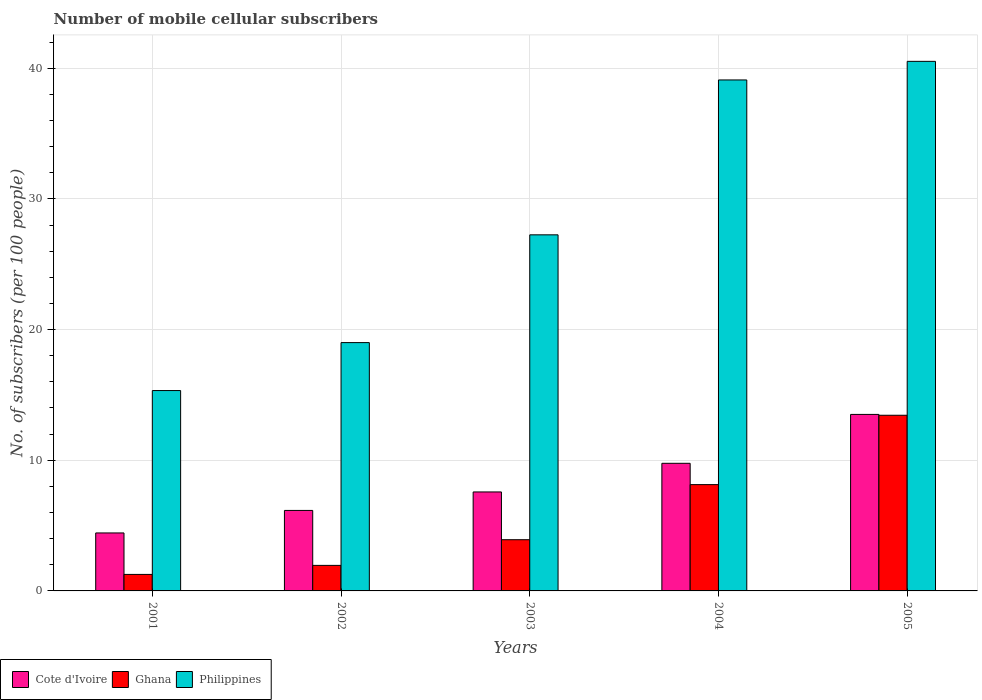How many different coloured bars are there?
Offer a very short reply. 3. How many groups of bars are there?
Keep it short and to the point. 5. Are the number of bars per tick equal to the number of legend labels?
Your response must be concise. Yes. How many bars are there on the 2nd tick from the left?
Your response must be concise. 3. What is the label of the 3rd group of bars from the left?
Keep it short and to the point. 2003. What is the number of mobile cellular subscribers in Philippines in 2002?
Your answer should be compact. 19. Across all years, what is the maximum number of mobile cellular subscribers in Ghana?
Your response must be concise. 13.44. Across all years, what is the minimum number of mobile cellular subscribers in Ghana?
Give a very brief answer. 1.26. In which year was the number of mobile cellular subscribers in Ghana minimum?
Your answer should be very brief. 2001. What is the total number of mobile cellular subscribers in Cote d'Ivoire in the graph?
Provide a short and direct response. 41.44. What is the difference between the number of mobile cellular subscribers in Cote d'Ivoire in 2004 and that in 2005?
Keep it short and to the point. -3.74. What is the difference between the number of mobile cellular subscribers in Cote d'Ivoire in 2001 and the number of mobile cellular subscribers in Ghana in 2004?
Make the answer very short. -3.7. What is the average number of mobile cellular subscribers in Philippines per year?
Offer a terse response. 28.24. In the year 2005, what is the difference between the number of mobile cellular subscribers in Philippines and number of mobile cellular subscribers in Cote d'Ivoire?
Offer a terse response. 27.02. In how many years, is the number of mobile cellular subscribers in Cote d'Ivoire greater than 32?
Keep it short and to the point. 0. What is the ratio of the number of mobile cellular subscribers in Philippines in 2001 to that in 2004?
Make the answer very short. 0.39. Is the number of mobile cellular subscribers in Cote d'Ivoire in 2003 less than that in 2005?
Make the answer very short. Yes. Is the difference between the number of mobile cellular subscribers in Philippines in 2002 and 2005 greater than the difference between the number of mobile cellular subscribers in Cote d'Ivoire in 2002 and 2005?
Offer a very short reply. No. What is the difference between the highest and the second highest number of mobile cellular subscribers in Ghana?
Provide a short and direct response. 5.31. What is the difference between the highest and the lowest number of mobile cellular subscribers in Cote d'Ivoire?
Give a very brief answer. 9.07. In how many years, is the number of mobile cellular subscribers in Cote d'Ivoire greater than the average number of mobile cellular subscribers in Cote d'Ivoire taken over all years?
Ensure brevity in your answer.  2. Is it the case that in every year, the sum of the number of mobile cellular subscribers in Ghana and number of mobile cellular subscribers in Cote d'Ivoire is greater than the number of mobile cellular subscribers in Philippines?
Provide a short and direct response. No. Are all the bars in the graph horizontal?
Provide a succinct answer. No. How many years are there in the graph?
Provide a short and direct response. 5. Are the values on the major ticks of Y-axis written in scientific E-notation?
Your response must be concise. No. Does the graph contain any zero values?
Make the answer very short. No. How many legend labels are there?
Give a very brief answer. 3. How are the legend labels stacked?
Provide a short and direct response. Horizontal. What is the title of the graph?
Offer a very short reply. Number of mobile cellular subscribers. Does "North America" appear as one of the legend labels in the graph?
Make the answer very short. No. What is the label or title of the Y-axis?
Ensure brevity in your answer.  No. of subscribers (per 100 people). What is the No. of subscribers (per 100 people) of Cote d'Ivoire in 2001?
Make the answer very short. 4.44. What is the No. of subscribers (per 100 people) in Ghana in 2001?
Your response must be concise. 1.26. What is the No. of subscribers (per 100 people) of Philippines in 2001?
Provide a succinct answer. 15.33. What is the No. of subscribers (per 100 people) in Cote d'Ivoire in 2002?
Offer a very short reply. 6.16. What is the No. of subscribers (per 100 people) in Ghana in 2002?
Offer a very short reply. 1.95. What is the No. of subscribers (per 100 people) in Philippines in 2002?
Offer a terse response. 19. What is the No. of subscribers (per 100 people) of Cote d'Ivoire in 2003?
Ensure brevity in your answer.  7.57. What is the No. of subscribers (per 100 people) in Ghana in 2003?
Provide a succinct answer. 3.92. What is the No. of subscribers (per 100 people) in Philippines in 2003?
Provide a succinct answer. 27.25. What is the No. of subscribers (per 100 people) of Cote d'Ivoire in 2004?
Offer a terse response. 9.77. What is the No. of subscribers (per 100 people) of Ghana in 2004?
Your answer should be compact. 8.14. What is the No. of subscribers (per 100 people) of Philippines in 2004?
Provide a succinct answer. 39.1. What is the No. of subscribers (per 100 people) in Cote d'Ivoire in 2005?
Provide a succinct answer. 13.51. What is the No. of subscribers (per 100 people) in Ghana in 2005?
Your answer should be compact. 13.44. What is the No. of subscribers (per 100 people) of Philippines in 2005?
Offer a very short reply. 40.52. Across all years, what is the maximum No. of subscribers (per 100 people) in Cote d'Ivoire?
Make the answer very short. 13.51. Across all years, what is the maximum No. of subscribers (per 100 people) in Ghana?
Make the answer very short. 13.44. Across all years, what is the maximum No. of subscribers (per 100 people) in Philippines?
Your response must be concise. 40.52. Across all years, what is the minimum No. of subscribers (per 100 people) in Cote d'Ivoire?
Your answer should be compact. 4.44. Across all years, what is the minimum No. of subscribers (per 100 people) of Ghana?
Ensure brevity in your answer.  1.26. Across all years, what is the minimum No. of subscribers (per 100 people) in Philippines?
Your answer should be very brief. 15.33. What is the total No. of subscribers (per 100 people) in Cote d'Ivoire in the graph?
Provide a short and direct response. 41.44. What is the total No. of subscribers (per 100 people) in Ghana in the graph?
Provide a succinct answer. 28.71. What is the total No. of subscribers (per 100 people) of Philippines in the graph?
Your answer should be very brief. 141.21. What is the difference between the No. of subscribers (per 100 people) of Cote d'Ivoire in 2001 and that in 2002?
Provide a succinct answer. -1.72. What is the difference between the No. of subscribers (per 100 people) of Ghana in 2001 and that in 2002?
Keep it short and to the point. -0.69. What is the difference between the No. of subscribers (per 100 people) of Philippines in 2001 and that in 2002?
Your answer should be very brief. -3.67. What is the difference between the No. of subscribers (per 100 people) in Cote d'Ivoire in 2001 and that in 2003?
Provide a succinct answer. -3.14. What is the difference between the No. of subscribers (per 100 people) of Ghana in 2001 and that in 2003?
Provide a succinct answer. -2.65. What is the difference between the No. of subscribers (per 100 people) in Philippines in 2001 and that in 2003?
Your answer should be compact. -11.92. What is the difference between the No. of subscribers (per 100 people) of Cote d'Ivoire in 2001 and that in 2004?
Your answer should be compact. -5.33. What is the difference between the No. of subscribers (per 100 people) of Ghana in 2001 and that in 2004?
Offer a terse response. -6.87. What is the difference between the No. of subscribers (per 100 people) in Philippines in 2001 and that in 2004?
Offer a terse response. -23.77. What is the difference between the No. of subscribers (per 100 people) of Cote d'Ivoire in 2001 and that in 2005?
Provide a short and direct response. -9.07. What is the difference between the No. of subscribers (per 100 people) in Ghana in 2001 and that in 2005?
Your answer should be very brief. -12.18. What is the difference between the No. of subscribers (per 100 people) of Philippines in 2001 and that in 2005?
Your answer should be compact. -25.19. What is the difference between the No. of subscribers (per 100 people) in Cote d'Ivoire in 2002 and that in 2003?
Offer a very short reply. -1.41. What is the difference between the No. of subscribers (per 100 people) in Ghana in 2002 and that in 2003?
Your response must be concise. -1.96. What is the difference between the No. of subscribers (per 100 people) in Philippines in 2002 and that in 2003?
Provide a succinct answer. -8.25. What is the difference between the No. of subscribers (per 100 people) of Cote d'Ivoire in 2002 and that in 2004?
Ensure brevity in your answer.  -3.61. What is the difference between the No. of subscribers (per 100 people) in Ghana in 2002 and that in 2004?
Ensure brevity in your answer.  -6.18. What is the difference between the No. of subscribers (per 100 people) of Philippines in 2002 and that in 2004?
Give a very brief answer. -20.1. What is the difference between the No. of subscribers (per 100 people) of Cote d'Ivoire in 2002 and that in 2005?
Offer a very short reply. -7.35. What is the difference between the No. of subscribers (per 100 people) in Ghana in 2002 and that in 2005?
Provide a short and direct response. -11.49. What is the difference between the No. of subscribers (per 100 people) in Philippines in 2002 and that in 2005?
Your response must be concise. -21.52. What is the difference between the No. of subscribers (per 100 people) of Cote d'Ivoire in 2003 and that in 2004?
Make the answer very short. -2.19. What is the difference between the No. of subscribers (per 100 people) in Ghana in 2003 and that in 2004?
Ensure brevity in your answer.  -4.22. What is the difference between the No. of subscribers (per 100 people) in Philippines in 2003 and that in 2004?
Offer a terse response. -11.85. What is the difference between the No. of subscribers (per 100 people) of Cote d'Ivoire in 2003 and that in 2005?
Your response must be concise. -5.93. What is the difference between the No. of subscribers (per 100 people) of Ghana in 2003 and that in 2005?
Your response must be concise. -9.52. What is the difference between the No. of subscribers (per 100 people) of Philippines in 2003 and that in 2005?
Give a very brief answer. -13.28. What is the difference between the No. of subscribers (per 100 people) of Cote d'Ivoire in 2004 and that in 2005?
Provide a short and direct response. -3.74. What is the difference between the No. of subscribers (per 100 people) in Ghana in 2004 and that in 2005?
Make the answer very short. -5.31. What is the difference between the No. of subscribers (per 100 people) in Philippines in 2004 and that in 2005?
Offer a terse response. -1.42. What is the difference between the No. of subscribers (per 100 people) in Cote d'Ivoire in 2001 and the No. of subscribers (per 100 people) in Ghana in 2002?
Keep it short and to the point. 2.48. What is the difference between the No. of subscribers (per 100 people) in Cote d'Ivoire in 2001 and the No. of subscribers (per 100 people) in Philippines in 2002?
Make the answer very short. -14.57. What is the difference between the No. of subscribers (per 100 people) in Ghana in 2001 and the No. of subscribers (per 100 people) in Philippines in 2002?
Provide a short and direct response. -17.74. What is the difference between the No. of subscribers (per 100 people) in Cote d'Ivoire in 2001 and the No. of subscribers (per 100 people) in Ghana in 2003?
Provide a succinct answer. 0.52. What is the difference between the No. of subscribers (per 100 people) of Cote d'Ivoire in 2001 and the No. of subscribers (per 100 people) of Philippines in 2003?
Your response must be concise. -22.81. What is the difference between the No. of subscribers (per 100 people) in Ghana in 2001 and the No. of subscribers (per 100 people) in Philippines in 2003?
Make the answer very short. -25.99. What is the difference between the No. of subscribers (per 100 people) in Cote d'Ivoire in 2001 and the No. of subscribers (per 100 people) in Ghana in 2004?
Your answer should be very brief. -3.7. What is the difference between the No. of subscribers (per 100 people) in Cote d'Ivoire in 2001 and the No. of subscribers (per 100 people) in Philippines in 2004?
Your response must be concise. -34.66. What is the difference between the No. of subscribers (per 100 people) in Ghana in 2001 and the No. of subscribers (per 100 people) in Philippines in 2004?
Your answer should be compact. -37.84. What is the difference between the No. of subscribers (per 100 people) in Cote d'Ivoire in 2001 and the No. of subscribers (per 100 people) in Ghana in 2005?
Keep it short and to the point. -9.01. What is the difference between the No. of subscribers (per 100 people) of Cote d'Ivoire in 2001 and the No. of subscribers (per 100 people) of Philippines in 2005?
Give a very brief answer. -36.09. What is the difference between the No. of subscribers (per 100 people) of Ghana in 2001 and the No. of subscribers (per 100 people) of Philippines in 2005?
Your response must be concise. -39.26. What is the difference between the No. of subscribers (per 100 people) in Cote d'Ivoire in 2002 and the No. of subscribers (per 100 people) in Ghana in 2003?
Offer a terse response. 2.24. What is the difference between the No. of subscribers (per 100 people) of Cote d'Ivoire in 2002 and the No. of subscribers (per 100 people) of Philippines in 2003?
Make the answer very short. -21.09. What is the difference between the No. of subscribers (per 100 people) in Ghana in 2002 and the No. of subscribers (per 100 people) in Philippines in 2003?
Make the answer very short. -25.3. What is the difference between the No. of subscribers (per 100 people) in Cote d'Ivoire in 2002 and the No. of subscribers (per 100 people) in Ghana in 2004?
Your answer should be very brief. -1.98. What is the difference between the No. of subscribers (per 100 people) of Cote d'Ivoire in 2002 and the No. of subscribers (per 100 people) of Philippines in 2004?
Offer a very short reply. -32.94. What is the difference between the No. of subscribers (per 100 people) of Ghana in 2002 and the No. of subscribers (per 100 people) of Philippines in 2004?
Give a very brief answer. -37.15. What is the difference between the No. of subscribers (per 100 people) of Cote d'Ivoire in 2002 and the No. of subscribers (per 100 people) of Ghana in 2005?
Offer a very short reply. -7.28. What is the difference between the No. of subscribers (per 100 people) of Cote d'Ivoire in 2002 and the No. of subscribers (per 100 people) of Philippines in 2005?
Make the answer very short. -34.37. What is the difference between the No. of subscribers (per 100 people) in Ghana in 2002 and the No. of subscribers (per 100 people) in Philippines in 2005?
Your response must be concise. -38.57. What is the difference between the No. of subscribers (per 100 people) of Cote d'Ivoire in 2003 and the No. of subscribers (per 100 people) of Ghana in 2004?
Your response must be concise. -0.56. What is the difference between the No. of subscribers (per 100 people) in Cote d'Ivoire in 2003 and the No. of subscribers (per 100 people) in Philippines in 2004?
Provide a succinct answer. -31.53. What is the difference between the No. of subscribers (per 100 people) in Ghana in 2003 and the No. of subscribers (per 100 people) in Philippines in 2004?
Ensure brevity in your answer.  -35.18. What is the difference between the No. of subscribers (per 100 people) of Cote d'Ivoire in 2003 and the No. of subscribers (per 100 people) of Ghana in 2005?
Offer a terse response. -5.87. What is the difference between the No. of subscribers (per 100 people) of Cote d'Ivoire in 2003 and the No. of subscribers (per 100 people) of Philippines in 2005?
Offer a terse response. -32.95. What is the difference between the No. of subscribers (per 100 people) in Ghana in 2003 and the No. of subscribers (per 100 people) in Philippines in 2005?
Provide a short and direct response. -36.61. What is the difference between the No. of subscribers (per 100 people) of Cote d'Ivoire in 2004 and the No. of subscribers (per 100 people) of Ghana in 2005?
Your response must be concise. -3.68. What is the difference between the No. of subscribers (per 100 people) of Cote d'Ivoire in 2004 and the No. of subscribers (per 100 people) of Philippines in 2005?
Provide a short and direct response. -30.76. What is the difference between the No. of subscribers (per 100 people) of Ghana in 2004 and the No. of subscribers (per 100 people) of Philippines in 2005?
Offer a terse response. -32.39. What is the average No. of subscribers (per 100 people) of Cote d'Ivoire per year?
Offer a terse response. 8.29. What is the average No. of subscribers (per 100 people) in Ghana per year?
Keep it short and to the point. 5.74. What is the average No. of subscribers (per 100 people) of Philippines per year?
Your response must be concise. 28.24. In the year 2001, what is the difference between the No. of subscribers (per 100 people) in Cote d'Ivoire and No. of subscribers (per 100 people) in Ghana?
Provide a succinct answer. 3.17. In the year 2001, what is the difference between the No. of subscribers (per 100 people) in Cote d'Ivoire and No. of subscribers (per 100 people) in Philippines?
Your answer should be very brief. -10.9. In the year 2001, what is the difference between the No. of subscribers (per 100 people) of Ghana and No. of subscribers (per 100 people) of Philippines?
Provide a short and direct response. -14.07. In the year 2002, what is the difference between the No. of subscribers (per 100 people) of Cote d'Ivoire and No. of subscribers (per 100 people) of Ghana?
Your response must be concise. 4.2. In the year 2002, what is the difference between the No. of subscribers (per 100 people) of Cote d'Ivoire and No. of subscribers (per 100 people) of Philippines?
Your answer should be very brief. -12.84. In the year 2002, what is the difference between the No. of subscribers (per 100 people) in Ghana and No. of subscribers (per 100 people) in Philippines?
Your answer should be compact. -17.05. In the year 2003, what is the difference between the No. of subscribers (per 100 people) of Cote d'Ivoire and No. of subscribers (per 100 people) of Ghana?
Make the answer very short. 3.66. In the year 2003, what is the difference between the No. of subscribers (per 100 people) of Cote d'Ivoire and No. of subscribers (per 100 people) of Philippines?
Your response must be concise. -19.68. In the year 2003, what is the difference between the No. of subscribers (per 100 people) in Ghana and No. of subscribers (per 100 people) in Philippines?
Offer a very short reply. -23.33. In the year 2004, what is the difference between the No. of subscribers (per 100 people) of Cote d'Ivoire and No. of subscribers (per 100 people) of Ghana?
Give a very brief answer. 1.63. In the year 2004, what is the difference between the No. of subscribers (per 100 people) in Cote d'Ivoire and No. of subscribers (per 100 people) in Philippines?
Make the answer very short. -29.34. In the year 2004, what is the difference between the No. of subscribers (per 100 people) of Ghana and No. of subscribers (per 100 people) of Philippines?
Make the answer very short. -30.97. In the year 2005, what is the difference between the No. of subscribers (per 100 people) of Cote d'Ivoire and No. of subscribers (per 100 people) of Ghana?
Make the answer very short. 0.06. In the year 2005, what is the difference between the No. of subscribers (per 100 people) of Cote d'Ivoire and No. of subscribers (per 100 people) of Philippines?
Give a very brief answer. -27.02. In the year 2005, what is the difference between the No. of subscribers (per 100 people) in Ghana and No. of subscribers (per 100 people) in Philippines?
Keep it short and to the point. -27.08. What is the ratio of the No. of subscribers (per 100 people) in Cote d'Ivoire in 2001 to that in 2002?
Give a very brief answer. 0.72. What is the ratio of the No. of subscribers (per 100 people) in Ghana in 2001 to that in 2002?
Offer a very short reply. 0.65. What is the ratio of the No. of subscribers (per 100 people) of Philippines in 2001 to that in 2002?
Your response must be concise. 0.81. What is the ratio of the No. of subscribers (per 100 people) of Cote d'Ivoire in 2001 to that in 2003?
Your answer should be compact. 0.59. What is the ratio of the No. of subscribers (per 100 people) of Ghana in 2001 to that in 2003?
Provide a short and direct response. 0.32. What is the ratio of the No. of subscribers (per 100 people) in Philippines in 2001 to that in 2003?
Offer a terse response. 0.56. What is the ratio of the No. of subscribers (per 100 people) of Cote d'Ivoire in 2001 to that in 2004?
Your answer should be very brief. 0.45. What is the ratio of the No. of subscribers (per 100 people) in Ghana in 2001 to that in 2004?
Offer a very short reply. 0.16. What is the ratio of the No. of subscribers (per 100 people) in Philippines in 2001 to that in 2004?
Give a very brief answer. 0.39. What is the ratio of the No. of subscribers (per 100 people) in Cote d'Ivoire in 2001 to that in 2005?
Your answer should be very brief. 0.33. What is the ratio of the No. of subscribers (per 100 people) in Ghana in 2001 to that in 2005?
Keep it short and to the point. 0.09. What is the ratio of the No. of subscribers (per 100 people) in Philippines in 2001 to that in 2005?
Keep it short and to the point. 0.38. What is the ratio of the No. of subscribers (per 100 people) in Cote d'Ivoire in 2002 to that in 2003?
Offer a terse response. 0.81. What is the ratio of the No. of subscribers (per 100 people) in Ghana in 2002 to that in 2003?
Keep it short and to the point. 0.5. What is the ratio of the No. of subscribers (per 100 people) in Philippines in 2002 to that in 2003?
Give a very brief answer. 0.7. What is the ratio of the No. of subscribers (per 100 people) of Cote d'Ivoire in 2002 to that in 2004?
Give a very brief answer. 0.63. What is the ratio of the No. of subscribers (per 100 people) in Ghana in 2002 to that in 2004?
Your response must be concise. 0.24. What is the ratio of the No. of subscribers (per 100 people) in Philippines in 2002 to that in 2004?
Give a very brief answer. 0.49. What is the ratio of the No. of subscribers (per 100 people) in Cote d'Ivoire in 2002 to that in 2005?
Your response must be concise. 0.46. What is the ratio of the No. of subscribers (per 100 people) in Ghana in 2002 to that in 2005?
Your response must be concise. 0.15. What is the ratio of the No. of subscribers (per 100 people) of Philippines in 2002 to that in 2005?
Keep it short and to the point. 0.47. What is the ratio of the No. of subscribers (per 100 people) of Cote d'Ivoire in 2003 to that in 2004?
Provide a succinct answer. 0.78. What is the ratio of the No. of subscribers (per 100 people) of Ghana in 2003 to that in 2004?
Your answer should be compact. 0.48. What is the ratio of the No. of subscribers (per 100 people) of Philippines in 2003 to that in 2004?
Ensure brevity in your answer.  0.7. What is the ratio of the No. of subscribers (per 100 people) of Cote d'Ivoire in 2003 to that in 2005?
Give a very brief answer. 0.56. What is the ratio of the No. of subscribers (per 100 people) of Ghana in 2003 to that in 2005?
Give a very brief answer. 0.29. What is the ratio of the No. of subscribers (per 100 people) in Philippines in 2003 to that in 2005?
Offer a terse response. 0.67. What is the ratio of the No. of subscribers (per 100 people) of Cote d'Ivoire in 2004 to that in 2005?
Your response must be concise. 0.72. What is the ratio of the No. of subscribers (per 100 people) in Ghana in 2004 to that in 2005?
Offer a very short reply. 0.61. What is the ratio of the No. of subscribers (per 100 people) in Philippines in 2004 to that in 2005?
Ensure brevity in your answer.  0.96. What is the difference between the highest and the second highest No. of subscribers (per 100 people) in Cote d'Ivoire?
Ensure brevity in your answer.  3.74. What is the difference between the highest and the second highest No. of subscribers (per 100 people) of Ghana?
Your response must be concise. 5.31. What is the difference between the highest and the second highest No. of subscribers (per 100 people) of Philippines?
Offer a terse response. 1.42. What is the difference between the highest and the lowest No. of subscribers (per 100 people) of Cote d'Ivoire?
Your answer should be very brief. 9.07. What is the difference between the highest and the lowest No. of subscribers (per 100 people) of Ghana?
Your response must be concise. 12.18. What is the difference between the highest and the lowest No. of subscribers (per 100 people) of Philippines?
Provide a short and direct response. 25.19. 